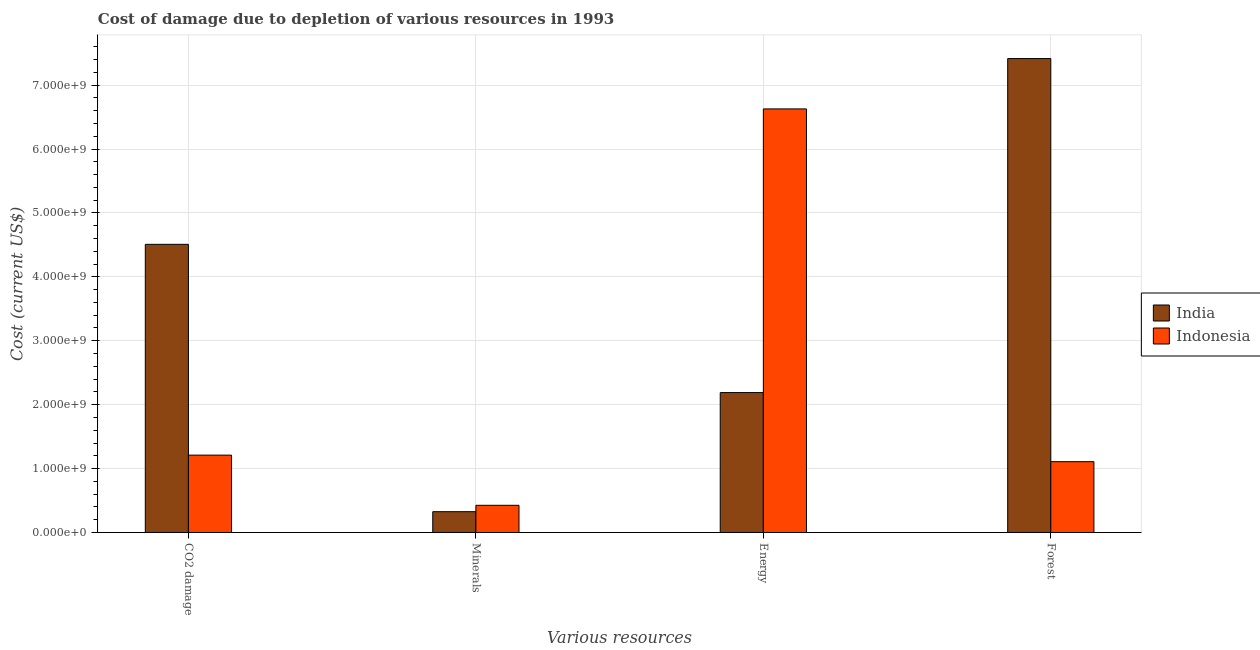How many groups of bars are there?
Your response must be concise. 4. Are the number of bars on each tick of the X-axis equal?
Your answer should be compact. Yes. What is the label of the 4th group of bars from the left?
Your answer should be compact. Forest. What is the cost of damage due to depletion of energy in Indonesia?
Your answer should be compact. 6.63e+09. Across all countries, what is the maximum cost of damage due to depletion of minerals?
Provide a short and direct response. 4.25e+08. Across all countries, what is the minimum cost of damage due to depletion of coal?
Provide a succinct answer. 1.21e+09. In which country was the cost of damage due to depletion of energy maximum?
Offer a terse response. Indonesia. In which country was the cost of damage due to depletion of coal minimum?
Your response must be concise. Indonesia. What is the total cost of damage due to depletion of forests in the graph?
Ensure brevity in your answer.  8.52e+09. What is the difference between the cost of damage due to depletion of energy in Indonesia and that in India?
Your response must be concise. 4.44e+09. What is the difference between the cost of damage due to depletion of minerals in Indonesia and the cost of damage due to depletion of coal in India?
Your answer should be compact. -4.08e+09. What is the average cost of damage due to depletion of coal per country?
Ensure brevity in your answer.  2.86e+09. What is the difference between the cost of damage due to depletion of energy and cost of damage due to depletion of coal in India?
Make the answer very short. -2.32e+09. In how many countries, is the cost of damage due to depletion of minerals greater than 5400000000 US$?
Provide a succinct answer. 0. What is the ratio of the cost of damage due to depletion of forests in India to that in Indonesia?
Your answer should be very brief. 6.69. Is the cost of damage due to depletion of minerals in India less than that in Indonesia?
Make the answer very short. Yes. What is the difference between the highest and the second highest cost of damage due to depletion of energy?
Offer a very short reply. 4.44e+09. What is the difference between the highest and the lowest cost of damage due to depletion of forests?
Make the answer very short. 6.31e+09. Is the sum of the cost of damage due to depletion of minerals in Indonesia and India greater than the maximum cost of damage due to depletion of coal across all countries?
Your answer should be very brief. No. What does the 1st bar from the left in Energy represents?
Your answer should be compact. India. Is it the case that in every country, the sum of the cost of damage due to depletion of coal and cost of damage due to depletion of minerals is greater than the cost of damage due to depletion of energy?
Provide a succinct answer. No. How many bars are there?
Your response must be concise. 8. How many countries are there in the graph?
Your answer should be very brief. 2. What is the difference between two consecutive major ticks on the Y-axis?
Offer a terse response. 1.00e+09. Does the graph contain any zero values?
Ensure brevity in your answer.  No. Does the graph contain grids?
Your response must be concise. Yes. How many legend labels are there?
Ensure brevity in your answer.  2. What is the title of the graph?
Offer a terse response. Cost of damage due to depletion of various resources in 1993 . Does "Rwanda" appear as one of the legend labels in the graph?
Keep it short and to the point. No. What is the label or title of the X-axis?
Your answer should be very brief. Various resources. What is the label or title of the Y-axis?
Provide a succinct answer. Cost (current US$). What is the Cost (current US$) of India in CO2 damage?
Give a very brief answer. 4.51e+09. What is the Cost (current US$) of Indonesia in CO2 damage?
Keep it short and to the point. 1.21e+09. What is the Cost (current US$) in India in Minerals?
Offer a very short reply. 3.26e+08. What is the Cost (current US$) in Indonesia in Minerals?
Offer a very short reply. 4.25e+08. What is the Cost (current US$) in India in Energy?
Keep it short and to the point. 2.19e+09. What is the Cost (current US$) in Indonesia in Energy?
Ensure brevity in your answer.  6.63e+09. What is the Cost (current US$) of India in Forest?
Your answer should be very brief. 7.42e+09. What is the Cost (current US$) in Indonesia in Forest?
Offer a terse response. 1.11e+09. Across all Various resources, what is the maximum Cost (current US$) in India?
Provide a succinct answer. 7.42e+09. Across all Various resources, what is the maximum Cost (current US$) in Indonesia?
Your answer should be compact. 6.63e+09. Across all Various resources, what is the minimum Cost (current US$) in India?
Offer a very short reply. 3.26e+08. Across all Various resources, what is the minimum Cost (current US$) in Indonesia?
Your response must be concise. 4.25e+08. What is the total Cost (current US$) in India in the graph?
Provide a succinct answer. 1.44e+1. What is the total Cost (current US$) of Indonesia in the graph?
Make the answer very short. 9.37e+09. What is the difference between the Cost (current US$) in India in CO2 damage and that in Minerals?
Ensure brevity in your answer.  4.18e+09. What is the difference between the Cost (current US$) of Indonesia in CO2 damage and that in Minerals?
Provide a short and direct response. 7.85e+08. What is the difference between the Cost (current US$) in India in CO2 damage and that in Energy?
Offer a terse response. 2.32e+09. What is the difference between the Cost (current US$) in Indonesia in CO2 damage and that in Energy?
Keep it short and to the point. -5.42e+09. What is the difference between the Cost (current US$) in India in CO2 damage and that in Forest?
Ensure brevity in your answer.  -2.91e+09. What is the difference between the Cost (current US$) in Indonesia in CO2 damage and that in Forest?
Keep it short and to the point. 1.03e+08. What is the difference between the Cost (current US$) of India in Minerals and that in Energy?
Make the answer very short. -1.86e+09. What is the difference between the Cost (current US$) of Indonesia in Minerals and that in Energy?
Your answer should be very brief. -6.20e+09. What is the difference between the Cost (current US$) of India in Minerals and that in Forest?
Give a very brief answer. -7.09e+09. What is the difference between the Cost (current US$) in Indonesia in Minerals and that in Forest?
Provide a short and direct response. -6.83e+08. What is the difference between the Cost (current US$) in India in Energy and that in Forest?
Keep it short and to the point. -5.23e+09. What is the difference between the Cost (current US$) in Indonesia in Energy and that in Forest?
Your response must be concise. 5.52e+09. What is the difference between the Cost (current US$) of India in CO2 damage and the Cost (current US$) of Indonesia in Minerals?
Provide a succinct answer. 4.08e+09. What is the difference between the Cost (current US$) of India in CO2 damage and the Cost (current US$) of Indonesia in Energy?
Your answer should be very brief. -2.12e+09. What is the difference between the Cost (current US$) of India in CO2 damage and the Cost (current US$) of Indonesia in Forest?
Your answer should be compact. 3.40e+09. What is the difference between the Cost (current US$) in India in Minerals and the Cost (current US$) in Indonesia in Energy?
Provide a short and direct response. -6.30e+09. What is the difference between the Cost (current US$) of India in Minerals and the Cost (current US$) of Indonesia in Forest?
Give a very brief answer. -7.82e+08. What is the difference between the Cost (current US$) of India in Energy and the Cost (current US$) of Indonesia in Forest?
Provide a succinct answer. 1.08e+09. What is the average Cost (current US$) of India per Various resources?
Ensure brevity in your answer.  3.61e+09. What is the average Cost (current US$) in Indonesia per Various resources?
Offer a terse response. 2.34e+09. What is the difference between the Cost (current US$) in India and Cost (current US$) in Indonesia in CO2 damage?
Offer a very short reply. 3.30e+09. What is the difference between the Cost (current US$) in India and Cost (current US$) in Indonesia in Minerals?
Provide a succinct answer. -9.97e+07. What is the difference between the Cost (current US$) in India and Cost (current US$) in Indonesia in Energy?
Ensure brevity in your answer.  -4.44e+09. What is the difference between the Cost (current US$) of India and Cost (current US$) of Indonesia in Forest?
Offer a terse response. 6.31e+09. What is the ratio of the Cost (current US$) of India in CO2 damage to that in Minerals?
Ensure brevity in your answer.  13.85. What is the ratio of the Cost (current US$) in Indonesia in CO2 damage to that in Minerals?
Give a very brief answer. 2.85. What is the ratio of the Cost (current US$) in India in CO2 damage to that in Energy?
Make the answer very short. 2.06. What is the ratio of the Cost (current US$) in Indonesia in CO2 damage to that in Energy?
Give a very brief answer. 0.18. What is the ratio of the Cost (current US$) in India in CO2 damage to that in Forest?
Your answer should be compact. 0.61. What is the ratio of the Cost (current US$) in Indonesia in CO2 damage to that in Forest?
Keep it short and to the point. 1.09. What is the ratio of the Cost (current US$) of India in Minerals to that in Energy?
Give a very brief answer. 0.15. What is the ratio of the Cost (current US$) of Indonesia in Minerals to that in Energy?
Provide a short and direct response. 0.06. What is the ratio of the Cost (current US$) of India in Minerals to that in Forest?
Your response must be concise. 0.04. What is the ratio of the Cost (current US$) in Indonesia in Minerals to that in Forest?
Your response must be concise. 0.38. What is the ratio of the Cost (current US$) of India in Energy to that in Forest?
Your response must be concise. 0.3. What is the ratio of the Cost (current US$) in Indonesia in Energy to that in Forest?
Provide a succinct answer. 5.98. What is the difference between the highest and the second highest Cost (current US$) of India?
Make the answer very short. 2.91e+09. What is the difference between the highest and the second highest Cost (current US$) in Indonesia?
Ensure brevity in your answer.  5.42e+09. What is the difference between the highest and the lowest Cost (current US$) in India?
Your answer should be compact. 7.09e+09. What is the difference between the highest and the lowest Cost (current US$) in Indonesia?
Offer a terse response. 6.20e+09. 